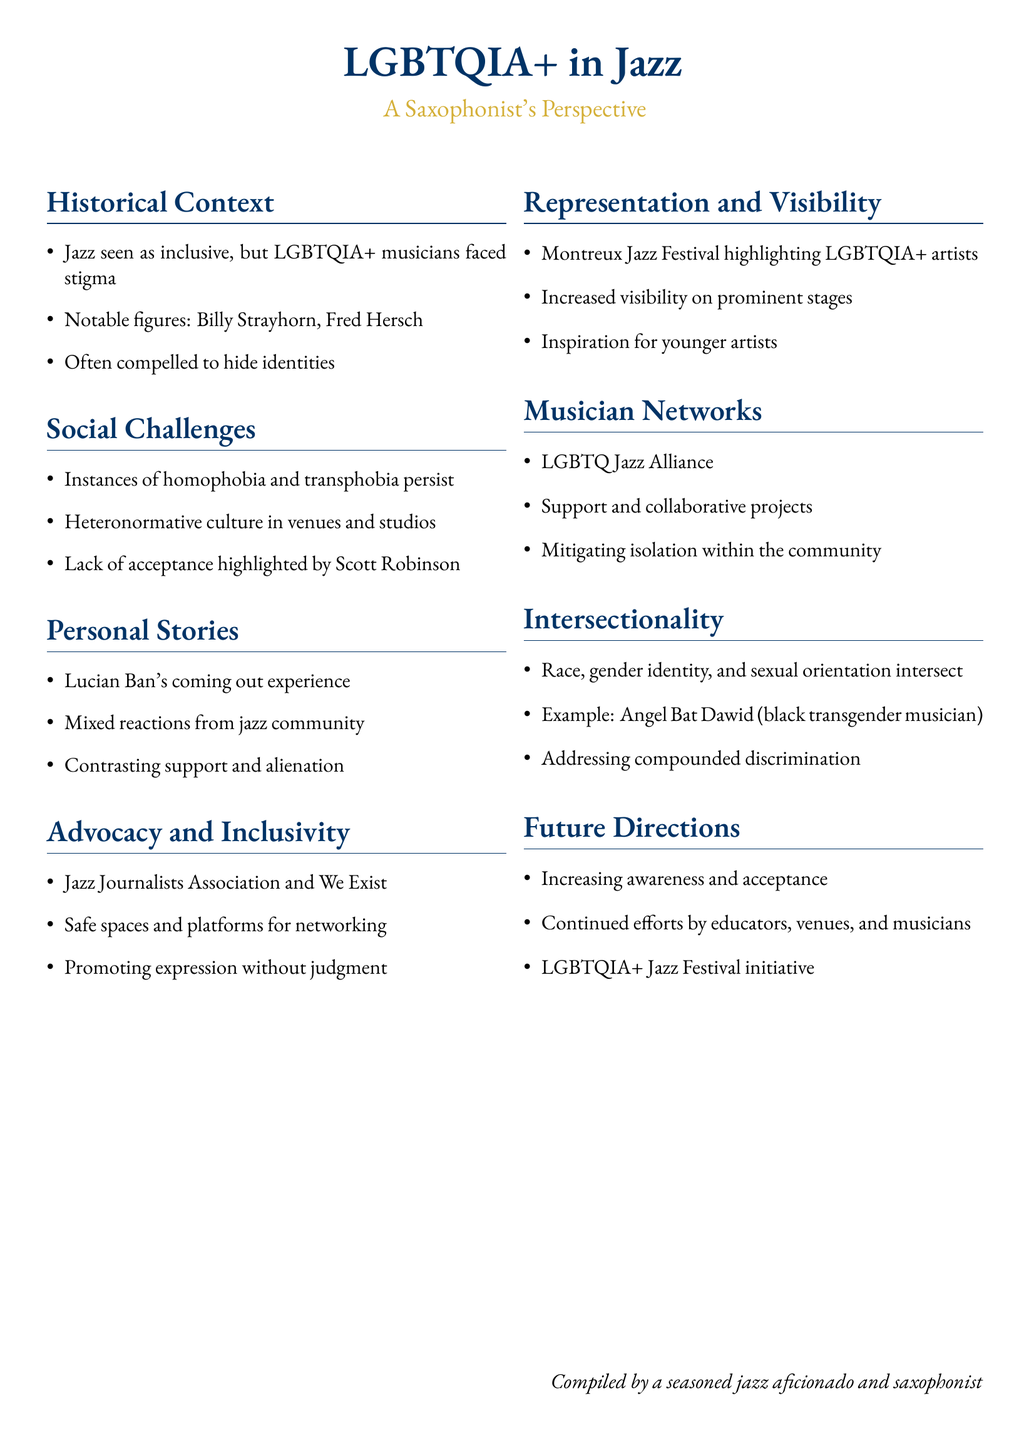What notable figures are mentioned in the document? The document lists notable figures in the Jazz scene such as Billy Strayhorn and Fred Hersch, highlighting their contributions and struggles as LGBTQIA+ musicians.
Answer: Billy Strayhorn, Fred Hersch What does the LGBTQIA+ Jazz Alliance provide? The document states that the LGBTQIA+ Jazz Alliance offers support and collaborative projects aimed at mitigating isolation within the community.
Answer: Support and collaborative projects Which festival emphasizes LGBTQIA+ artists? The document mentions the Montreux Jazz Festival as an event that highlights LGBTQIA+ artists, showcasing their work and increasing visibility.
Answer: Montreux Jazz Festival What issue is highlighted by Scott Robinson? The document indicates that Scott Robinson highlights the lack of acceptance within the jazz community, which is characterized by continued homophobia and transphobia.
Answer: Lack of acceptance Who experienced mixed reactions after coming out? Lucian Ban’s experience after coming out is discussed in the document, indicating he faced both support and alienation within the jazz community.
Answer: Lucian Ban What initiative is mentioned for future directions? The document discusses the LGBTQIA+ Jazz Festival initiative as a future direction for increasing awareness and acceptance of LGBTQIA+ musicians in jazz.
Answer: LGBTQIA+ Jazz Festival initiative What is the relationship between race, gender identity, and sexual orientation? The document addresses the concept of intersectionality, emphasizing how race, gender identity, and sexual orientation intersect, resulting in compounded discrimination for some musicians.
Answer: Intersectionality What organizations are mentioned as part of advocacy? The document includes the Jazz Journalists Association and We Exist as some organizations involved in advocating for LGBTQIA+ inclusivity in jazz.
Answer: Jazz Journalists Association, We Exist How are younger artists inspired according to the document? The increased visibility of LGBTQIA+ artists on prominent stages provides inspiration for younger artists pursuing their careers in music and jazz specifically.
Answer: Increased visibility on prominent stages 